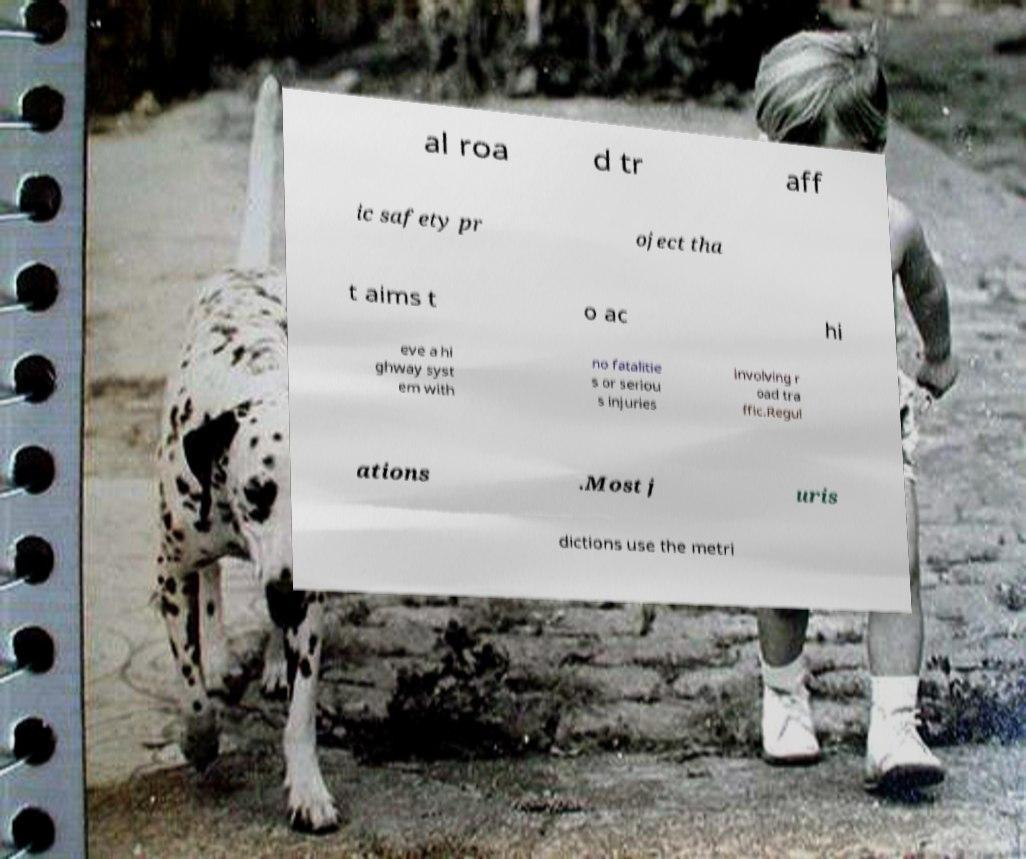Can you accurately transcribe the text from the provided image for me? al roa d tr aff ic safety pr oject tha t aims t o ac hi eve a hi ghway syst em with no fatalitie s or seriou s injuries involving r oad tra ffic.Regul ations .Most j uris dictions use the metri 